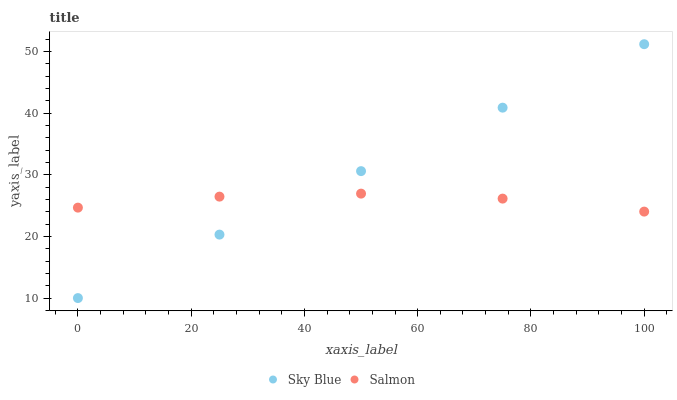Does Salmon have the minimum area under the curve?
Answer yes or no. Yes. Does Sky Blue have the maximum area under the curve?
Answer yes or no. Yes. Does Salmon have the maximum area under the curve?
Answer yes or no. No. Is Sky Blue the smoothest?
Answer yes or no. Yes. Is Salmon the roughest?
Answer yes or no. Yes. Is Salmon the smoothest?
Answer yes or no. No. Does Sky Blue have the lowest value?
Answer yes or no. Yes. Does Salmon have the lowest value?
Answer yes or no. No. Does Sky Blue have the highest value?
Answer yes or no. Yes. Does Salmon have the highest value?
Answer yes or no. No. Does Sky Blue intersect Salmon?
Answer yes or no. Yes. Is Sky Blue less than Salmon?
Answer yes or no. No. Is Sky Blue greater than Salmon?
Answer yes or no. No. 